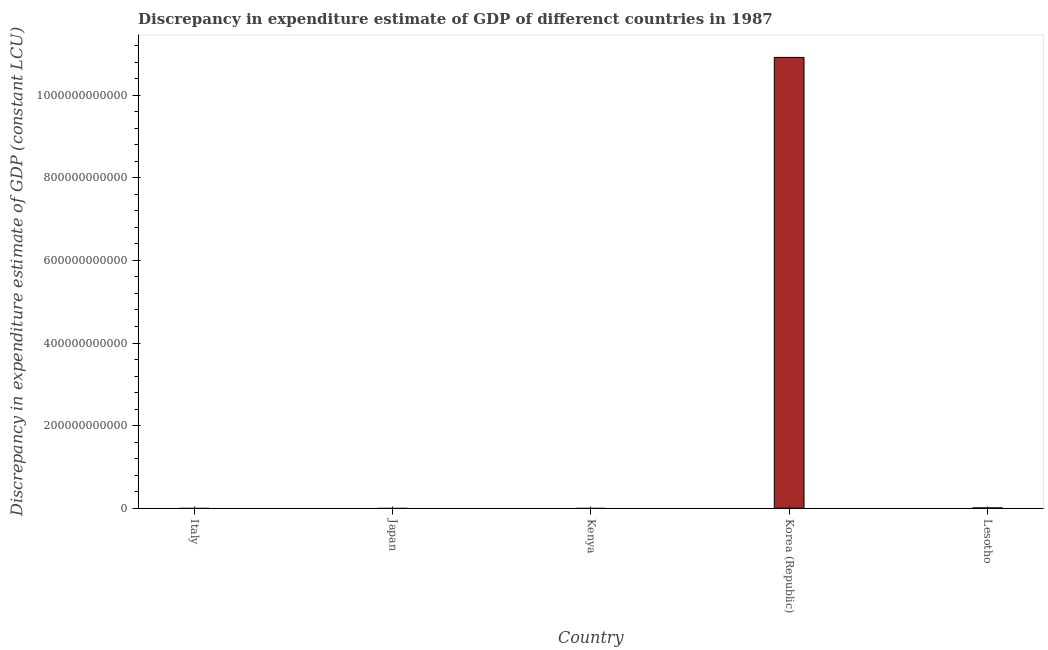Does the graph contain grids?
Your response must be concise. No. What is the title of the graph?
Provide a short and direct response. Discrepancy in expenditure estimate of GDP of differenct countries in 1987. What is the label or title of the X-axis?
Make the answer very short. Country. What is the label or title of the Y-axis?
Offer a terse response. Discrepancy in expenditure estimate of GDP (constant LCU). Across all countries, what is the maximum discrepancy in expenditure estimate of gdp?
Your response must be concise. 1.09e+12. What is the sum of the discrepancy in expenditure estimate of gdp?
Provide a succinct answer. 1.09e+12. What is the average discrepancy in expenditure estimate of gdp per country?
Keep it short and to the point. 2.18e+11. What is the ratio of the discrepancy in expenditure estimate of gdp in Korea (Republic) to that in Lesotho?
Keep it short and to the point. 1170.2. What is the difference between the highest and the lowest discrepancy in expenditure estimate of gdp?
Ensure brevity in your answer.  1.09e+12. In how many countries, is the discrepancy in expenditure estimate of gdp greater than the average discrepancy in expenditure estimate of gdp taken over all countries?
Your answer should be compact. 1. How many bars are there?
Provide a succinct answer. 2. Are all the bars in the graph horizontal?
Offer a terse response. No. What is the difference between two consecutive major ticks on the Y-axis?
Your response must be concise. 2.00e+11. What is the Discrepancy in expenditure estimate of GDP (constant LCU) of Japan?
Keep it short and to the point. 0. What is the Discrepancy in expenditure estimate of GDP (constant LCU) in Kenya?
Your answer should be very brief. 0. What is the Discrepancy in expenditure estimate of GDP (constant LCU) in Korea (Republic)?
Keep it short and to the point. 1.09e+12. What is the Discrepancy in expenditure estimate of GDP (constant LCU) of Lesotho?
Make the answer very short. 9.33e+08. What is the difference between the Discrepancy in expenditure estimate of GDP (constant LCU) in Korea (Republic) and Lesotho?
Your answer should be compact. 1.09e+12. What is the ratio of the Discrepancy in expenditure estimate of GDP (constant LCU) in Korea (Republic) to that in Lesotho?
Keep it short and to the point. 1170.2. 